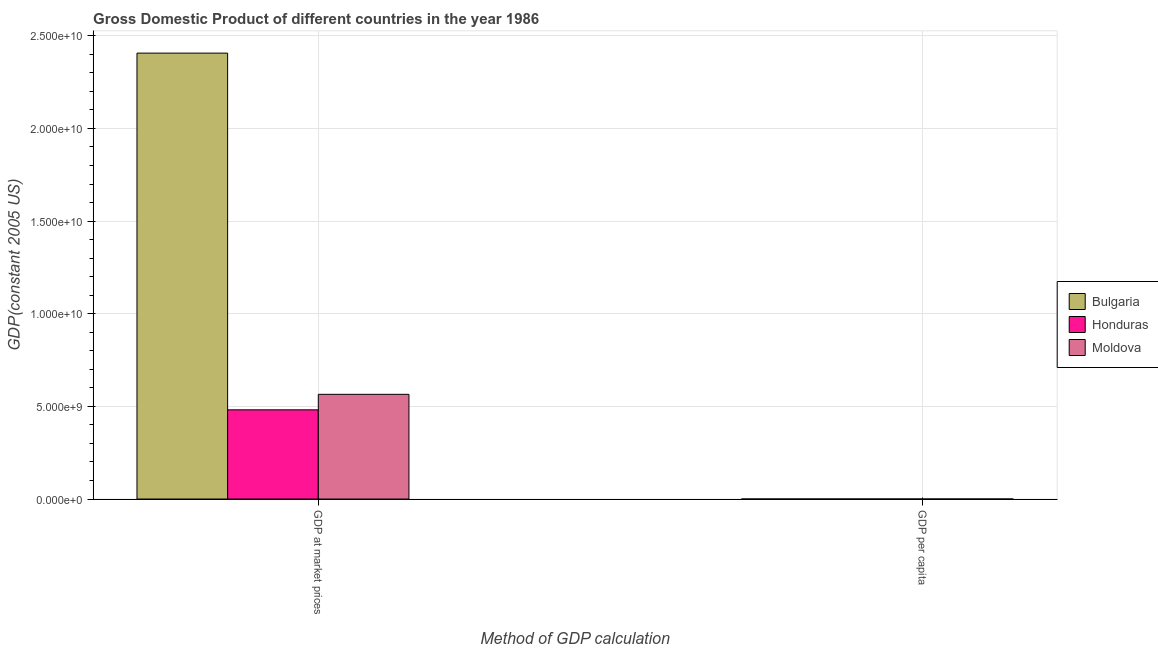How many bars are there on the 2nd tick from the left?
Your answer should be very brief. 3. How many bars are there on the 1st tick from the right?
Your answer should be compact. 3. What is the label of the 1st group of bars from the left?
Your answer should be very brief. GDP at market prices. What is the gdp at market prices in Moldova?
Your answer should be very brief. 5.65e+09. Across all countries, what is the maximum gdp per capita?
Your response must be concise. 2686.41. Across all countries, what is the minimum gdp at market prices?
Keep it short and to the point. 4.81e+09. In which country was the gdp at market prices maximum?
Ensure brevity in your answer.  Bulgaria. In which country was the gdp per capita minimum?
Keep it short and to the point. Honduras. What is the total gdp at market prices in the graph?
Your answer should be very brief. 3.45e+1. What is the difference between the gdp at market prices in Bulgaria and that in Honduras?
Offer a very short reply. 1.93e+1. What is the difference between the gdp per capita in Moldova and the gdp at market prices in Honduras?
Offer a terse response. -4.81e+09. What is the average gdp per capita per country?
Provide a succinct answer. 1785.94. What is the difference between the gdp per capita and gdp at market prices in Moldova?
Your response must be concise. -5.65e+09. In how many countries, is the gdp per capita greater than 4000000000 US$?
Give a very brief answer. 0. What is the ratio of the gdp per capita in Moldova to that in Honduras?
Provide a succinct answer. 1.42. In how many countries, is the gdp per capita greater than the average gdp per capita taken over all countries?
Your response must be concise. 1. What does the 1st bar from the left in GDP per capita represents?
Provide a short and direct response. Bulgaria. What does the 1st bar from the right in GDP at market prices represents?
Your answer should be very brief. Moldova. How many bars are there?
Offer a terse response. 6. Are all the bars in the graph horizontal?
Your answer should be compact. No. What is the difference between two consecutive major ticks on the Y-axis?
Make the answer very short. 5.00e+09. Are the values on the major ticks of Y-axis written in scientific E-notation?
Your response must be concise. Yes. Where does the legend appear in the graph?
Your response must be concise. Center right. How many legend labels are there?
Your response must be concise. 3. How are the legend labels stacked?
Give a very brief answer. Vertical. What is the title of the graph?
Provide a succinct answer. Gross Domestic Product of different countries in the year 1986. What is the label or title of the X-axis?
Make the answer very short. Method of GDP calculation. What is the label or title of the Y-axis?
Keep it short and to the point. GDP(constant 2005 US). What is the GDP(constant 2005 US) in Bulgaria in GDP at market prices?
Keep it short and to the point. 2.41e+1. What is the GDP(constant 2005 US) in Honduras in GDP at market prices?
Your response must be concise. 4.81e+09. What is the GDP(constant 2005 US) in Moldova in GDP at market prices?
Make the answer very short. 5.65e+09. What is the GDP(constant 2005 US) in Bulgaria in GDP per capita?
Keep it short and to the point. 2686.41. What is the GDP(constant 2005 US) of Honduras in GDP per capita?
Your response must be concise. 1102.55. What is the GDP(constant 2005 US) in Moldova in GDP per capita?
Provide a short and direct response. 1568.87. Across all Method of GDP calculation, what is the maximum GDP(constant 2005 US) of Bulgaria?
Ensure brevity in your answer.  2.41e+1. Across all Method of GDP calculation, what is the maximum GDP(constant 2005 US) in Honduras?
Your response must be concise. 4.81e+09. Across all Method of GDP calculation, what is the maximum GDP(constant 2005 US) in Moldova?
Provide a succinct answer. 5.65e+09. Across all Method of GDP calculation, what is the minimum GDP(constant 2005 US) in Bulgaria?
Your answer should be compact. 2686.41. Across all Method of GDP calculation, what is the minimum GDP(constant 2005 US) in Honduras?
Give a very brief answer. 1102.55. Across all Method of GDP calculation, what is the minimum GDP(constant 2005 US) of Moldova?
Your response must be concise. 1568.87. What is the total GDP(constant 2005 US) of Bulgaria in the graph?
Make the answer very short. 2.41e+1. What is the total GDP(constant 2005 US) of Honduras in the graph?
Your answer should be compact. 4.81e+09. What is the total GDP(constant 2005 US) in Moldova in the graph?
Provide a succinct answer. 5.65e+09. What is the difference between the GDP(constant 2005 US) of Bulgaria in GDP at market prices and that in GDP per capita?
Your response must be concise. 2.41e+1. What is the difference between the GDP(constant 2005 US) of Honduras in GDP at market prices and that in GDP per capita?
Give a very brief answer. 4.81e+09. What is the difference between the GDP(constant 2005 US) in Moldova in GDP at market prices and that in GDP per capita?
Make the answer very short. 5.65e+09. What is the difference between the GDP(constant 2005 US) of Bulgaria in GDP at market prices and the GDP(constant 2005 US) of Honduras in GDP per capita?
Offer a terse response. 2.41e+1. What is the difference between the GDP(constant 2005 US) in Bulgaria in GDP at market prices and the GDP(constant 2005 US) in Moldova in GDP per capita?
Provide a short and direct response. 2.41e+1. What is the difference between the GDP(constant 2005 US) of Honduras in GDP at market prices and the GDP(constant 2005 US) of Moldova in GDP per capita?
Give a very brief answer. 4.81e+09. What is the average GDP(constant 2005 US) in Bulgaria per Method of GDP calculation?
Make the answer very short. 1.20e+1. What is the average GDP(constant 2005 US) of Honduras per Method of GDP calculation?
Your answer should be compact. 2.41e+09. What is the average GDP(constant 2005 US) of Moldova per Method of GDP calculation?
Keep it short and to the point. 2.83e+09. What is the difference between the GDP(constant 2005 US) of Bulgaria and GDP(constant 2005 US) of Honduras in GDP at market prices?
Offer a very short reply. 1.93e+1. What is the difference between the GDP(constant 2005 US) of Bulgaria and GDP(constant 2005 US) of Moldova in GDP at market prices?
Make the answer very short. 1.84e+1. What is the difference between the GDP(constant 2005 US) in Honduras and GDP(constant 2005 US) in Moldova in GDP at market prices?
Provide a short and direct response. -8.37e+08. What is the difference between the GDP(constant 2005 US) of Bulgaria and GDP(constant 2005 US) of Honduras in GDP per capita?
Offer a terse response. 1583.87. What is the difference between the GDP(constant 2005 US) of Bulgaria and GDP(constant 2005 US) of Moldova in GDP per capita?
Keep it short and to the point. 1117.54. What is the difference between the GDP(constant 2005 US) in Honduras and GDP(constant 2005 US) in Moldova in GDP per capita?
Provide a short and direct response. -466.33. What is the ratio of the GDP(constant 2005 US) in Bulgaria in GDP at market prices to that in GDP per capita?
Your answer should be very brief. 8.96e+06. What is the ratio of the GDP(constant 2005 US) in Honduras in GDP at market prices to that in GDP per capita?
Ensure brevity in your answer.  4.37e+06. What is the ratio of the GDP(constant 2005 US) in Moldova in GDP at market prices to that in GDP per capita?
Offer a terse response. 3.60e+06. What is the difference between the highest and the second highest GDP(constant 2005 US) in Bulgaria?
Your answer should be very brief. 2.41e+1. What is the difference between the highest and the second highest GDP(constant 2005 US) of Honduras?
Keep it short and to the point. 4.81e+09. What is the difference between the highest and the second highest GDP(constant 2005 US) in Moldova?
Your answer should be very brief. 5.65e+09. What is the difference between the highest and the lowest GDP(constant 2005 US) in Bulgaria?
Keep it short and to the point. 2.41e+1. What is the difference between the highest and the lowest GDP(constant 2005 US) in Honduras?
Give a very brief answer. 4.81e+09. What is the difference between the highest and the lowest GDP(constant 2005 US) of Moldova?
Give a very brief answer. 5.65e+09. 